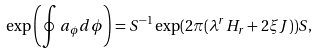<formula> <loc_0><loc_0><loc_500><loc_500>\exp \left ( \oint a _ { \phi } d \phi \right ) = S ^ { - 1 } \exp ( 2 \pi ( \lambda ^ { r } H _ { r } + 2 \xi J ) ) S ,</formula> 